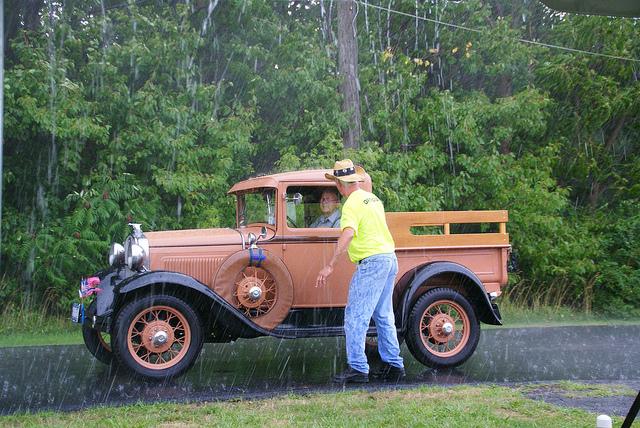What type of hat is the man wearing?
Quick response, please. Cowboy. How many people are in the picture?
Keep it brief. 2. Is there a house in the background?
Concise answer only. No. Is anyone driving this truck?
Write a very short answer. Yes. What color is the truck?
Be succinct. Brown. What State is the truck registered in?
Keep it brief. Georgia. Is that a modern day vehicle?
Be succinct. No. Does the tree have leaves?
Answer briefly. Yes. How many wheels does this have?
Short answer required. 4. 